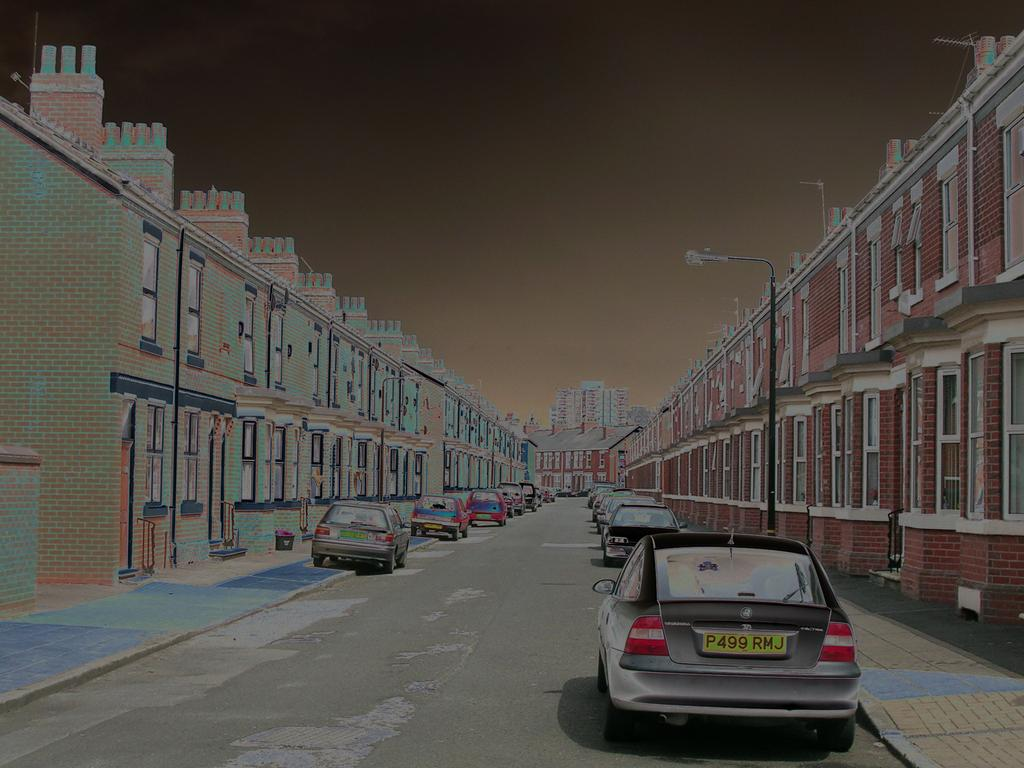How was the image altered or modified? The image is edited, which means it has been manipulated or changed in some way. What type of structures can be seen in the image? There are buildings in the image. What are the tall, thin objects with lights on them in the image? There are light poles in the image. What is moving along the road in the image? There are vehicles on the road in the image. What is visible at the top of the image? The sky is visible at the top of the image. What type of ant is crawling on the buildings in the image? There are no ants present in the image; it features buildings, light poles, vehicles, and a sky. What event caused the buildings to be covered in a layer of dust in the image? There is no indication of any event or cause for a layer of dust on the buildings in the image. 